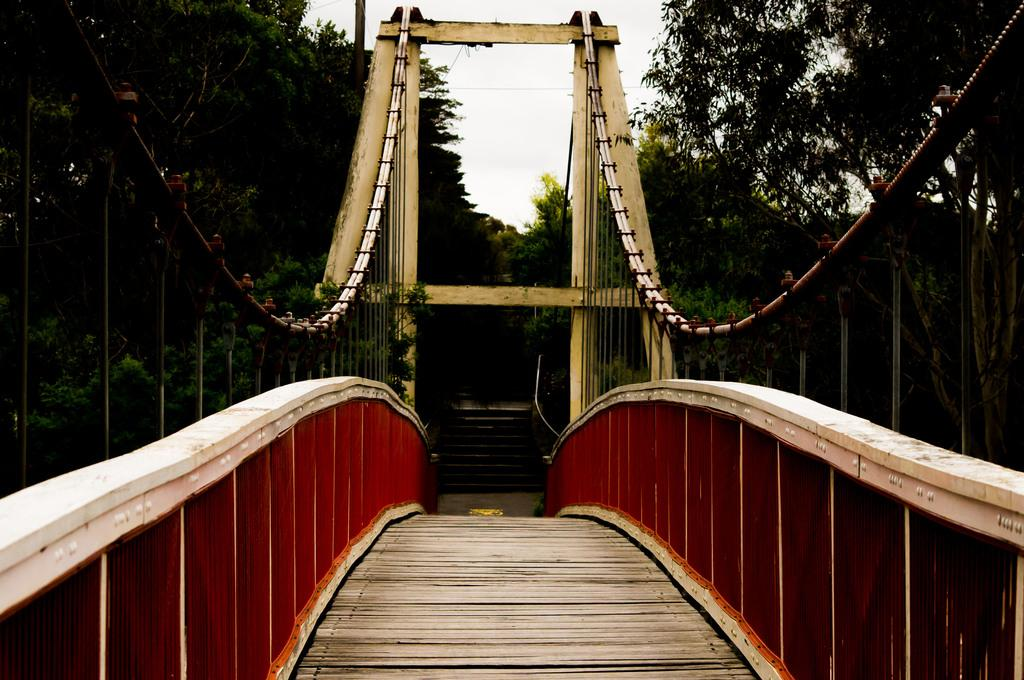What type of structure can be seen in the image? There is a bridge in the image. What architectural feature is also present in the image? There is a staircase in the image. What type of vegetation is visible in the image? There are trees in the image. What is visible in the background of the image? The sky is visible in the image. What type of chain can be seen hanging from the trees in the image? There is no chain present in the image; it only features a bridge, a staircase, trees, and the sky. 